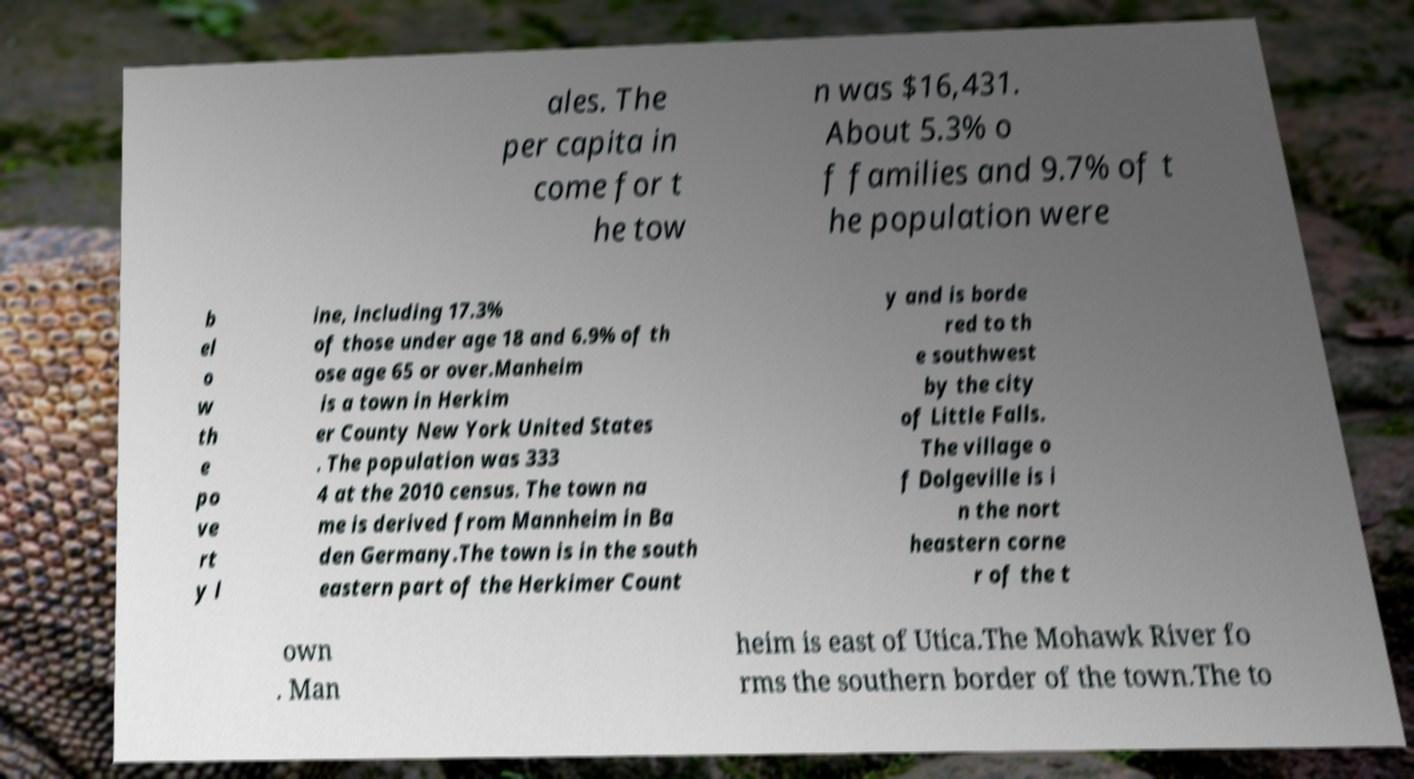Please identify and transcribe the text found in this image. ales. The per capita in come for t he tow n was $16,431. About 5.3% o f families and 9.7% of t he population were b el o w th e po ve rt y l ine, including 17.3% of those under age 18 and 6.9% of th ose age 65 or over.Manheim is a town in Herkim er County New York United States . The population was 333 4 at the 2010 census. The town na me is derived from Mannheim in Ba den Germany.The town is in the south eastern part of the Herkimer Count y and is borde red to th e southwest by the city of Little Falls. The village o f Dolgeville is i n the nort heastern corne r of the t own . Man heim is east of Utica.The Mohawk River fo rms the southern border of the town.The to 